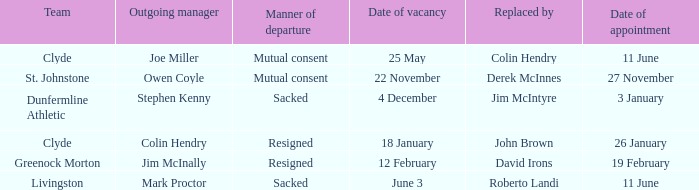Tell me the outgoing manager for livingston Mark Proctor. 